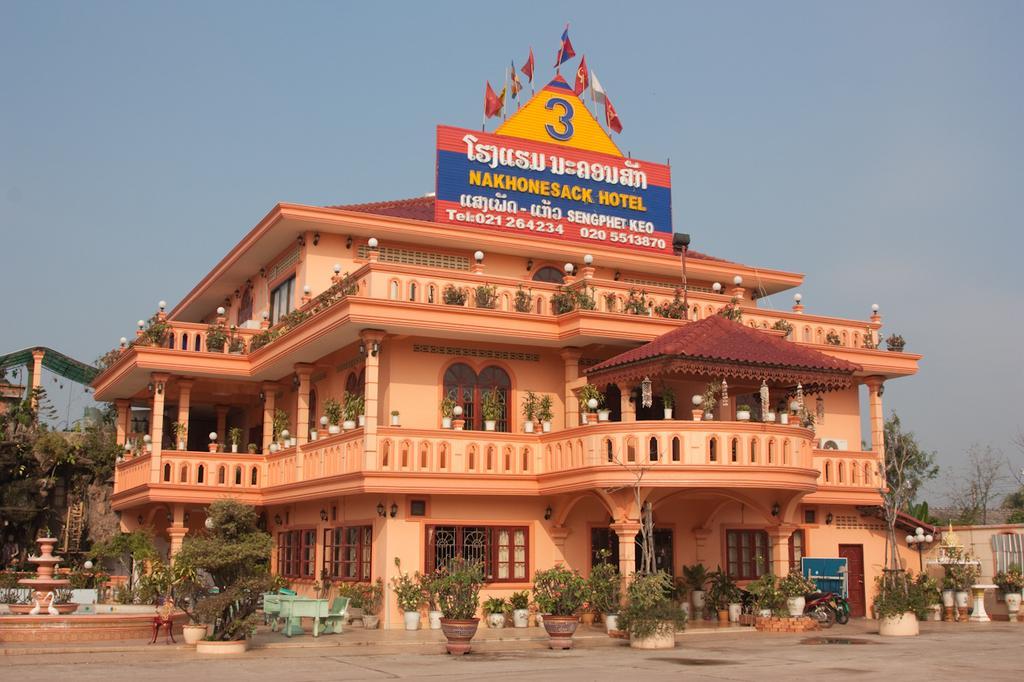In one or two sentences, can you explain what this image depicts? In this image there is a building at the center. On top of the building there are flags. In front of the building there are plants. At the background there are trees and sky. Beside the building there is a fountain. 